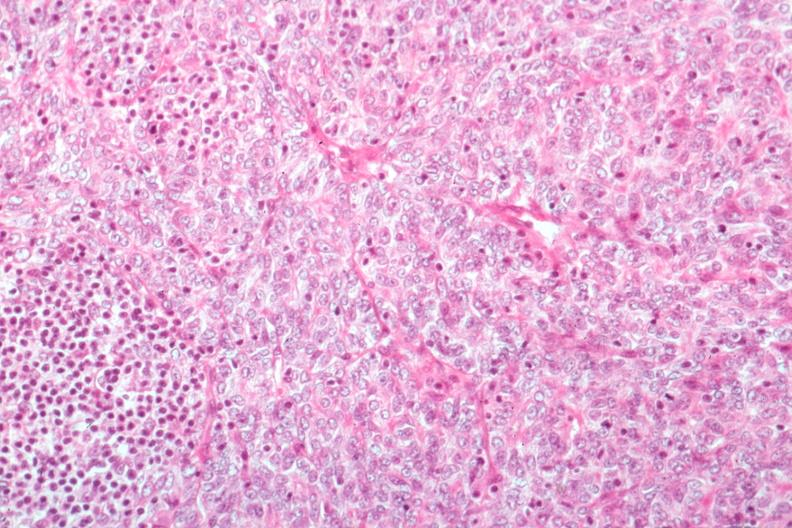does acute myelogenous leukemia show predominant epithelial excellent histology?
Answer the question using a single word or phrase. No 